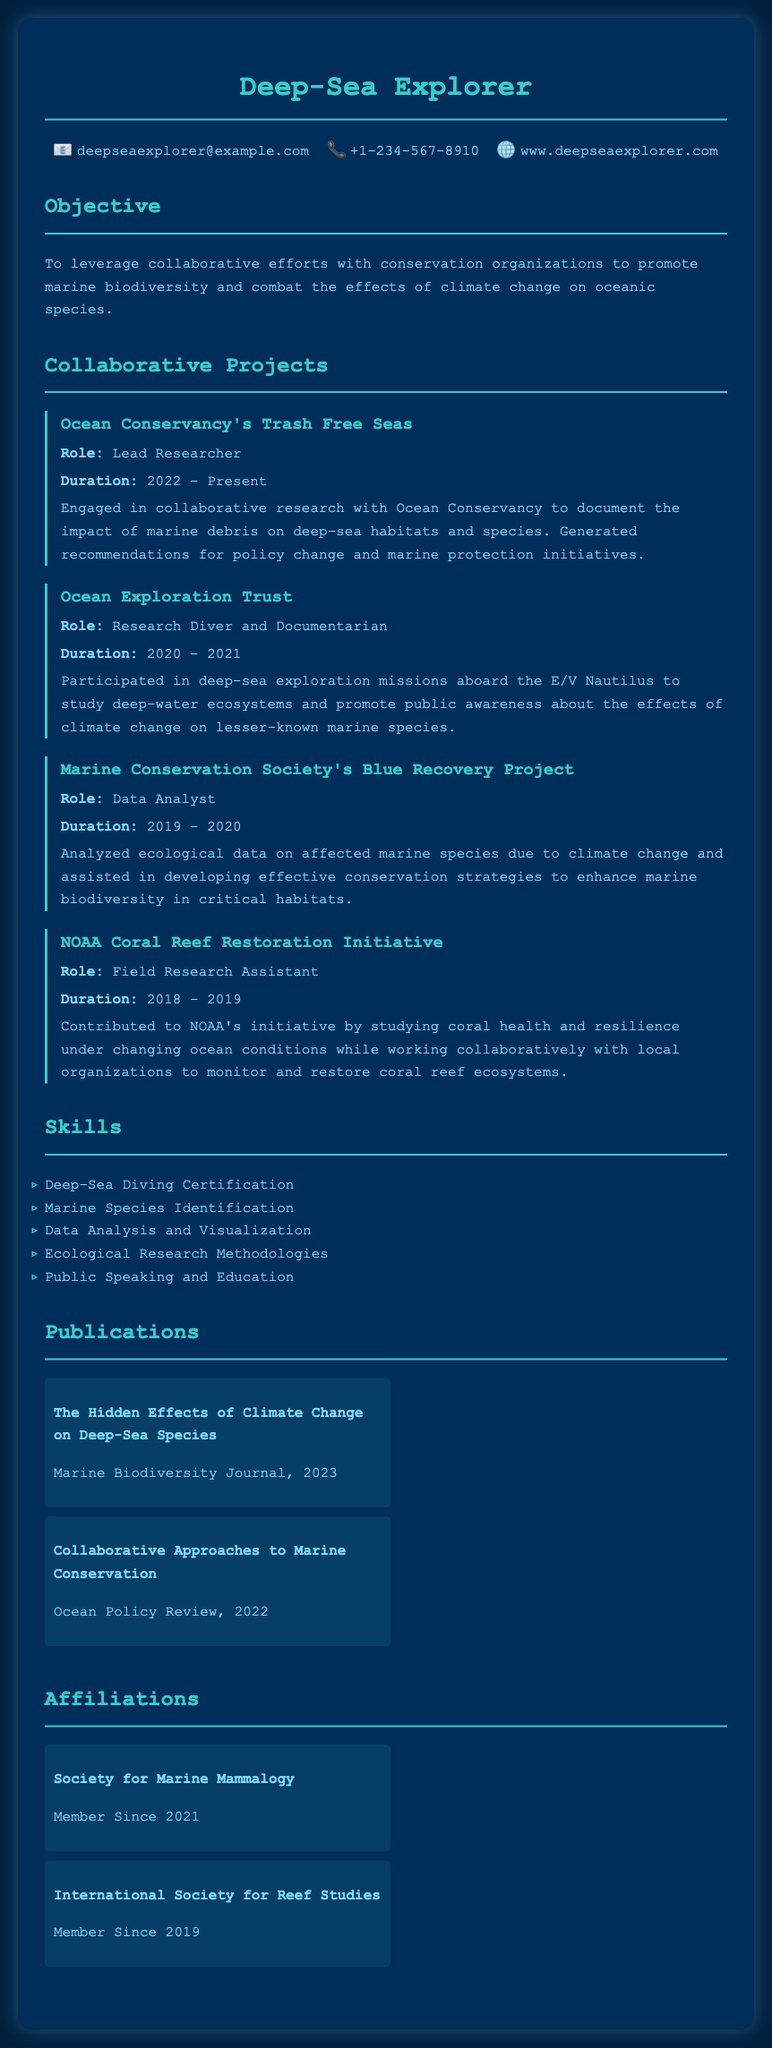what is the role in Ocean Conservancy's Trash Free Seas? The role listed in the document is Lead Researcher for the collaborative project with Ocean Conservancy.
Answer: Lead Researcher what was the duration of the project with the Marine Conservation Society? The document indicates that the duration of the project with the Marine Conservation Society's Blue Recovery Project was from 2019 to 2020.
Answer: 2019 - 2020 which organization is associated with the initiative studied under changing ocean conditions? The document states that NOAA's Coral Reef Restoration Initiative is associated with the study of coral health under changing conditions.
Answer: NOAA how many publications are listed in the document? The document lists two publications related to marine biodiversity and collaborative approaches to conservation.
Answer: 2 what is one skill mentioned in the CV? The document outlines several skills; one example is Deep-Sea Diving Certification.
Answer: Deep-Sea Diving Certification what is the main objective stated in the CV? The document mentions an objective to leverage collaborative efforts with conservation organizations for marine biodiversity.
Answer: promote marine biodiversity who was involved in deep-sea exploration missions aboard the E/V Nautilus? The document specifies that the person in the CV participated in deep-sea exploration missions as a Research Diver and Documentarian.
Answer: Research Diver and Documentarian when did the work as a Data Analyst for the Blue Recovery Project take place? The document indicates that the role as a Data Analyst for the Blue Recovery Project occurred between 2019 and 2020.
Answer: 2019 - 2020 what is the name of the second publication? The document lists the second publication as "Collaborative Approaches to Marine Conservation."
Answer: Collaborative Approaches to Marine Conservation 